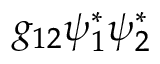Convert formula to latex. <formula><loc_0><loc_0><loc_500><loc_500>g _ { 1 2 } \psi _ { 1 } ^ { * } \psi _ { 2 } ^ { * }</formula> 